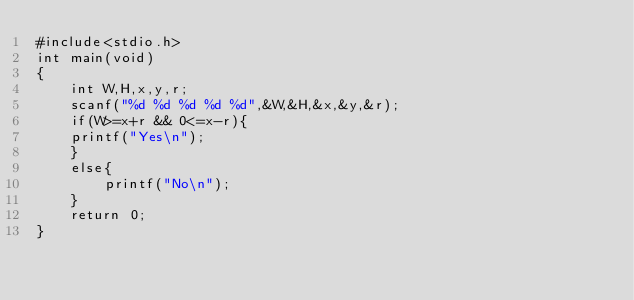<code> <loc_0><loc_0><loc_500><loc_500><_C_>#include<stdio.h>
int main(void)
{
	int W,H,x,y,r;
	scanf("%d %d %d %d %d",&W,&H,&x,&y,&r);
	if(W>=x+r && 0<=x-r){
	printf("Yes\n");
	}
	else{
		printf("No\n");
	}
	return 0;
}</code> 